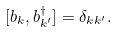Convert formula to latex. <formula><loc_0><loc_0><loc_500><loc_500>[ b _ { k } , b _ { k ^ { \prime } } ^ { \dagger } ] = \delta _ { k k ^ { \prime } } .</formula> 